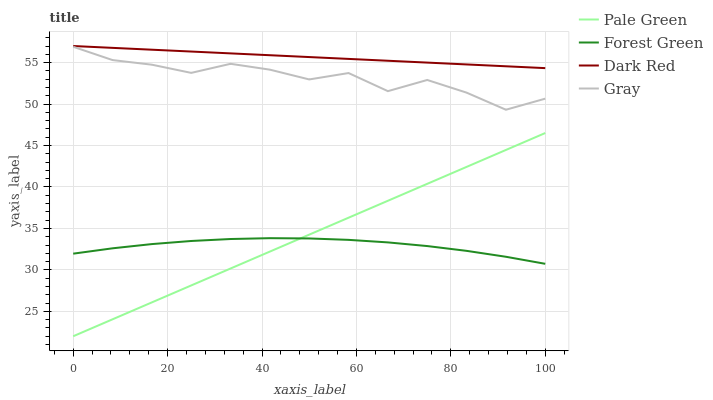Does Forest Green have the minimum area under the curve?
Answer yes or no. Yes. Does Dark Red have the maximum area under the curve?
Answer yes or no. Yes. Does Pale Green have the minimum area under the curve?
Answer yes or no. No. Does Pale Green have the maximum area under the curve?
Answer yes or no. No. Is Dark Red the smoothest?
Answer yes or no. Yes. Is Gray the roughest?
Answer yes or no. Yes. Is Forest Green the smoothest?
Answer yes or no. No. Is Forest Green the roughest?
Answer yes or no. No. Does Pale Green have the lowest value?
Answer yes or no. Yes. Does Forest Green have the lowest value?
Answer yes or no. No. Does Dark Red have the highest value?
Answer yes or no. Yes. Does Pale Green have the highest value?
Answer yes or no. No. Is Pale Green less than Dark Red?
Answer yes or no. Yes. Is Gray greater than Forest Green?
Answer yes or no. Yes. Does Pale Green intersect Forest Green?
Answer yes or no. Yes. Is Pale Green less than Forest Green?
Answer yes or no. No. Is Pale Green greater than Forest Green?
Answer yes or no. No. Does Pale Green intersect Dark Red?
Answer yes or no. No. 